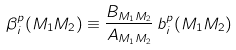<formula> <loc_0><loc_0><loc_500><loc_500>\beta _ { i } ^ { p } ( M _ { 1 } M _ { 2 } ) \equiv \frac { B _ { M _ { 1 } M _ { 2 } } } { A _ { M _ { 1 } M _ { 2 } } } \, b _ { i } ^ { p } ( M _ { 1 } M _ { 2 } )</formula> 